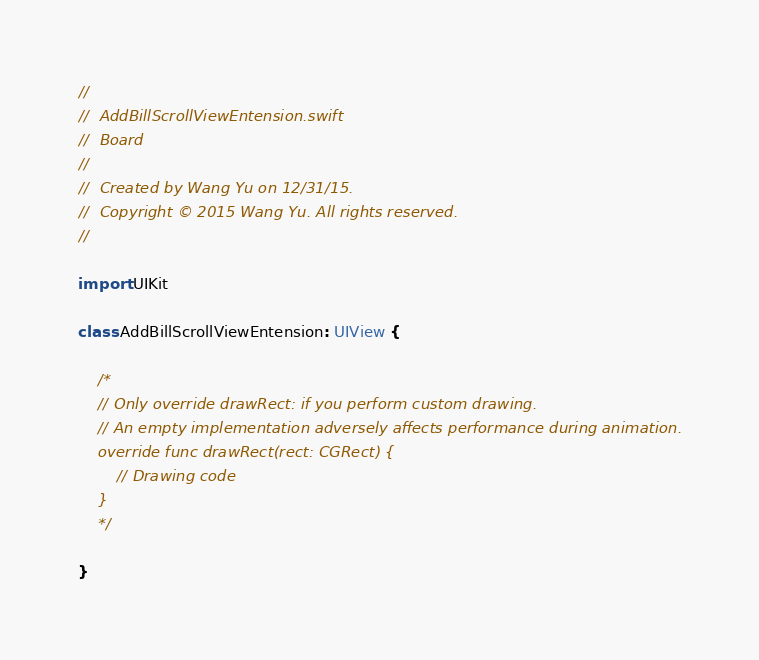<code> <loc_0><loc_0><loc_500><loc_500><_Swift_>//
//  AddBillScrollViewEntension.swift
//  Board
//
//  Created by Wang Yu on 12/31/15.
//  Copyright © 2015 Wang Yu. All rights reserved.
//

import UIKit

class AddBillScrollViewEntension: UIView {

    /*
    // Only override drawRect: if you perform custom drawing.
    // An empty implementation adversely affects performance during animation.
    override func drawRect(rect: CGRect) {
        // Drawing code
    }
    */

}
</code> 